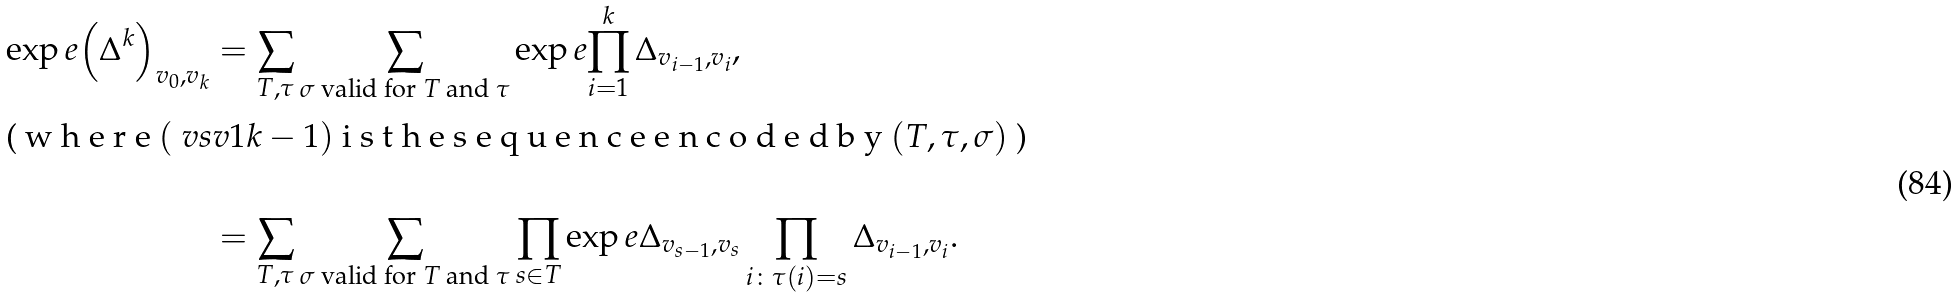<formula> <loc_0><loc_0><loc_500><loc_500>\exp e { \left ( \Delta ^ { k } \right ) _ { v _ { 0 } , v _ { k } } } & = \sum _ { T , \tau } \sum _ { \text {$\sigma$ valid for $T$ and $\tau $} } \exp e { \prod _ { i = 1 } ^ { k } \Delta _ { v _ { i - 1 } , v _ { i } } } , \intertext { ( w h e r e $ ( \ v s { v } { 1 } { k - 1 } ) $ i s t h e s e q u e n c e e n c o d e d b y $ ( T , \tau , \sigma ) $ ) } \\ & = \sum _ { T , \tau } \sum _ { \text {$\sigma$ valid for $T$ and $\tau $} } \prod _ { s \in T } \exp e { \Delta _ { v _ { s - 1 } , v _ { s } } \prod _ { i \colon \tau ( i ) = s } \Delta _ { v _ { i - 1 } , v _ { i } } } .</formula> 